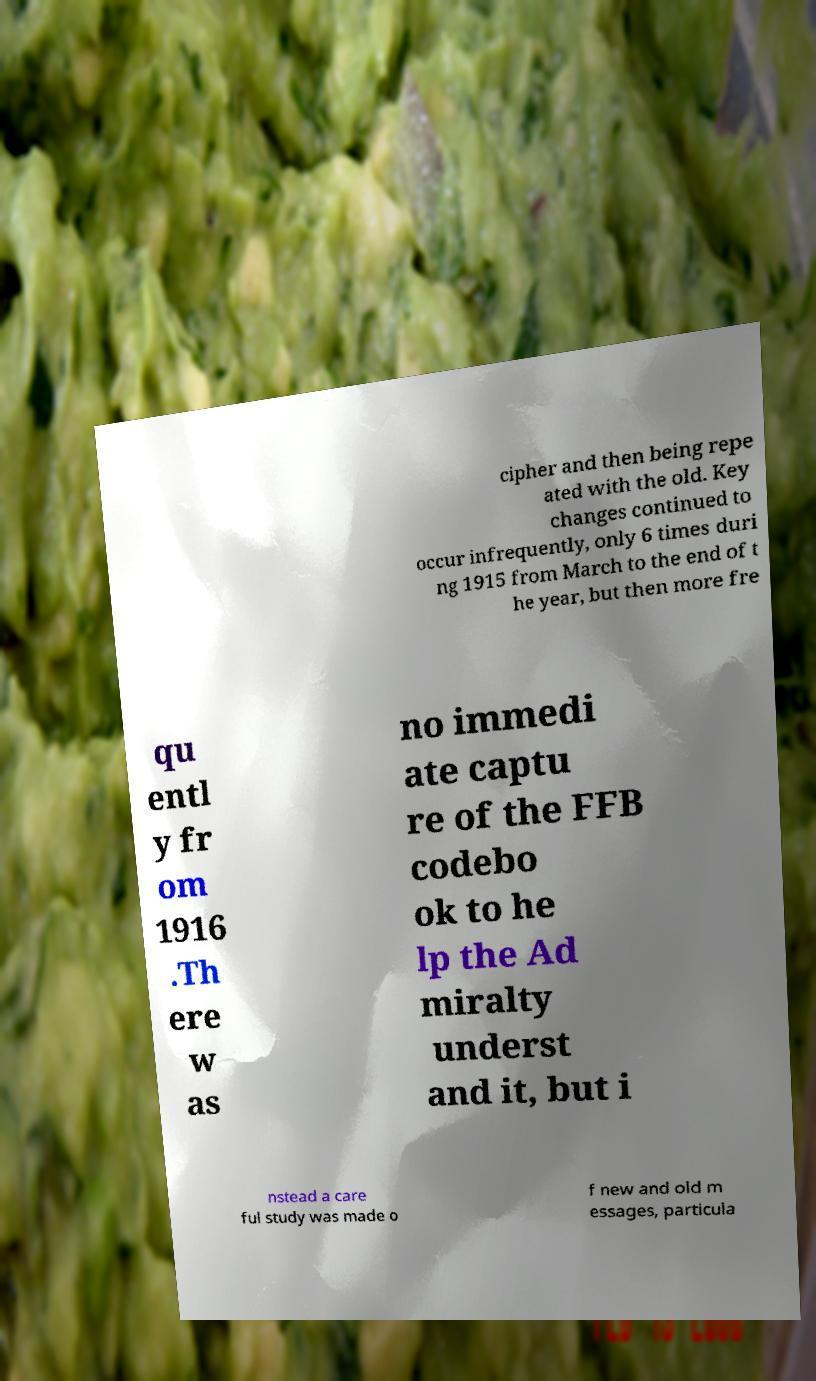Please identify and transcribe the text found in this image. cipher and then being repe ated with the old. Key changes continued to occur infrequently, only 6 times duri ng 1915 from March to the end of t he year, but then more fre qu entl y fr om 1916 .Th ere w as no immedi ate captu re of the FFB codebo ok to he lp the Ad miralty underst and it, but i nstead a care ful study was made o f new and old m essages, particula 